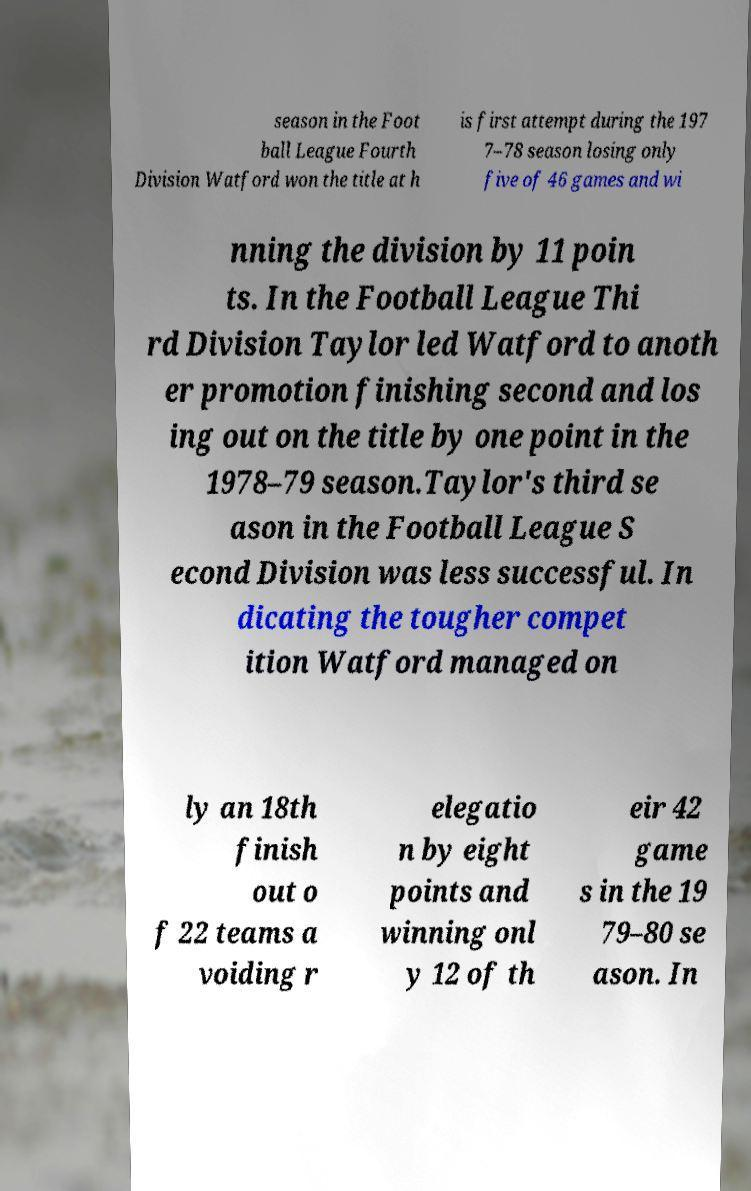Please identify and transcribe the text found in this image. season in the Foot ball League Fourth Division Watford won the title at h is first attempt during the 197 7–78 season losing only five of 46 games and wi nning the division by 11 poin ts. In the Football League Thi rd Division Taylor led Watford to anoth er promotion finishing second and los ing out on the title by one point in the 1978–79 season.Taylor's third se ason in the Football League S econd Division was less successful. In dicating the tougher compet ition Watford managed on ly an 18th finish out o f 22 teams a voiding r elegatio n by eight points and winning onl y 12 of th eir 42 game s in the 19 79–80 se ason. In 